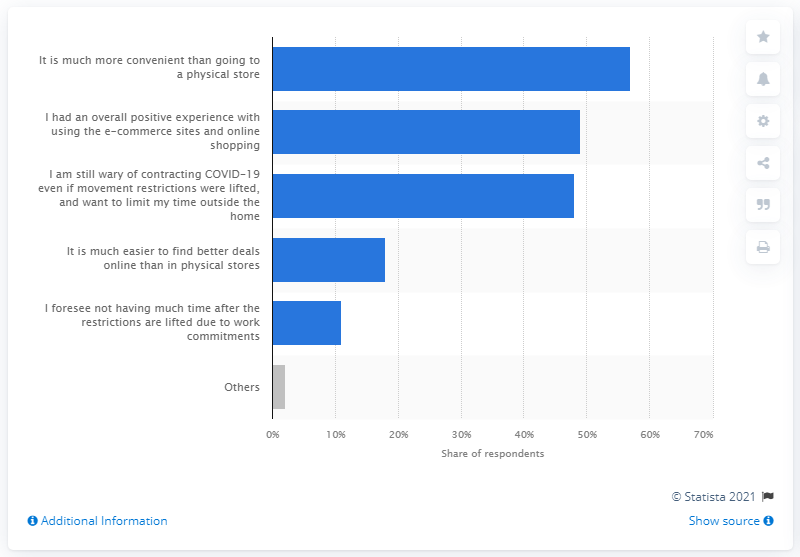List a handful of essential elements in this visual. A majority of Filipinos, at 57%, stated that they would continue to purchase products or services online. 